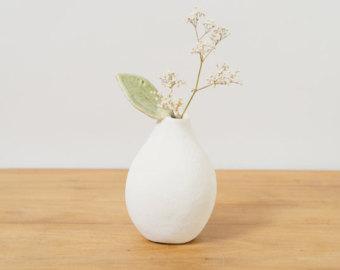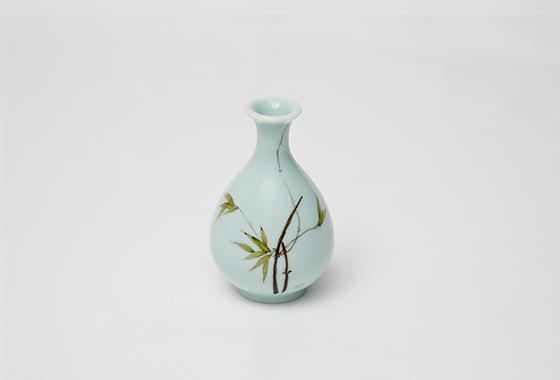The first image is the image on the left, the second image is the image on the right. For the images displayed, is the sentence "There are 2 pieces of fruit sitting next to a vase." factually correct? Answer yes or no. No. The first image is the image on the left, the second image is the image on the right. Assess this claim about the two images: "In the right side image, there is a plant in only one of the vases.". Correct or not? Answer yes or no. No. 